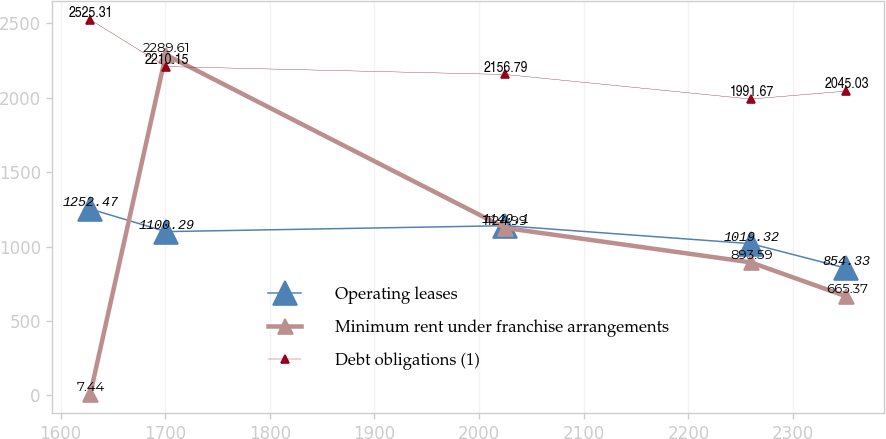Convert chart to OTSL. <chart><loc_0><loc_0><loc_500><loc_500><line_chart><ecel><fcel>Operating leases<fcel>Minimum rent under franchise arrangements<fcel>Debt obligations (1)<nl><fcel>1628.35<fcel>1252.47<fcel>7.44<fcel>2525.31<nl><fcel>1700.59<fcel>1100.29<fcel>2289.61<fcel>2210.15<nl><fcel>2024.91<fcel>1140.1<fcel>1124.99<fcel>2156.79<nl><fcel>2259.63<fcel>1019.32<fcel>893.59<fcel>1991.67<nl><fcel>2350.75<fcel>854.33<fcel>665.37<fcel>2045.03<nl></chart> 